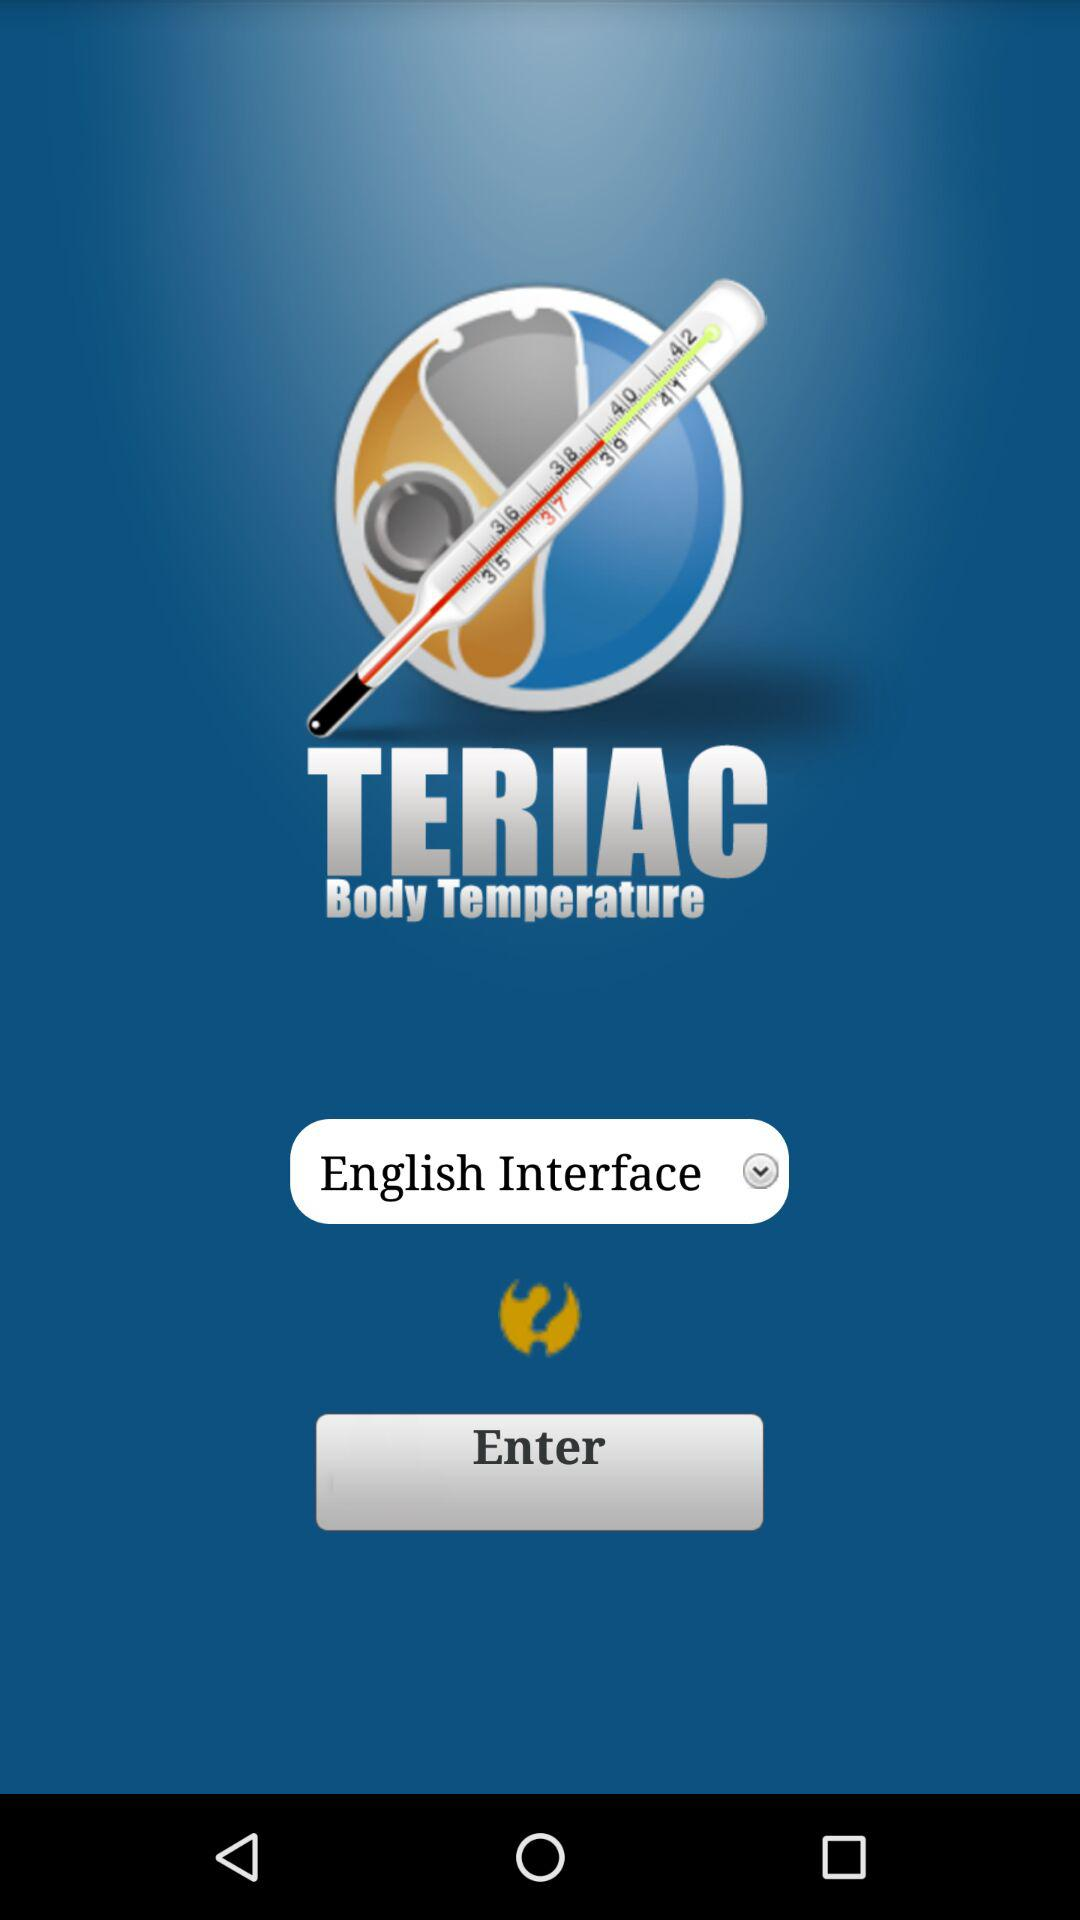What is the app name? The app name is "Body Temperature". 